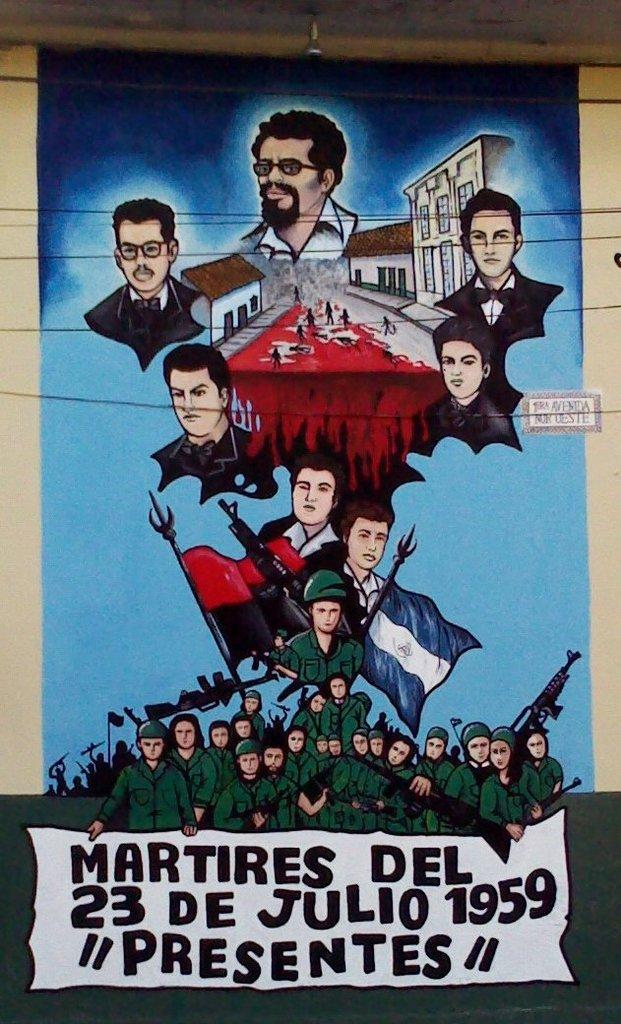<image>
Summarize the visual content of the image. A sign that says MARTIRES DEL on the bottom. 